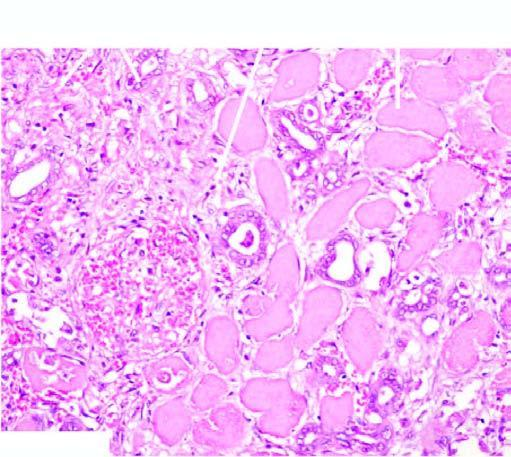s there acute inflammatory infiltrate at the periphery of the infarct?
Answer the question using a single word or phrase. Yes 